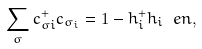<formula> <loc_0><loc_0><loc_500><loc_500>\sum _ { \sigma } { c } _ { \sigma i } ^ { + } { c } _ { \sigma _ { i } } = 1 - h _ { i } ^ { + } h _ { i } \ e n ,</formula> 